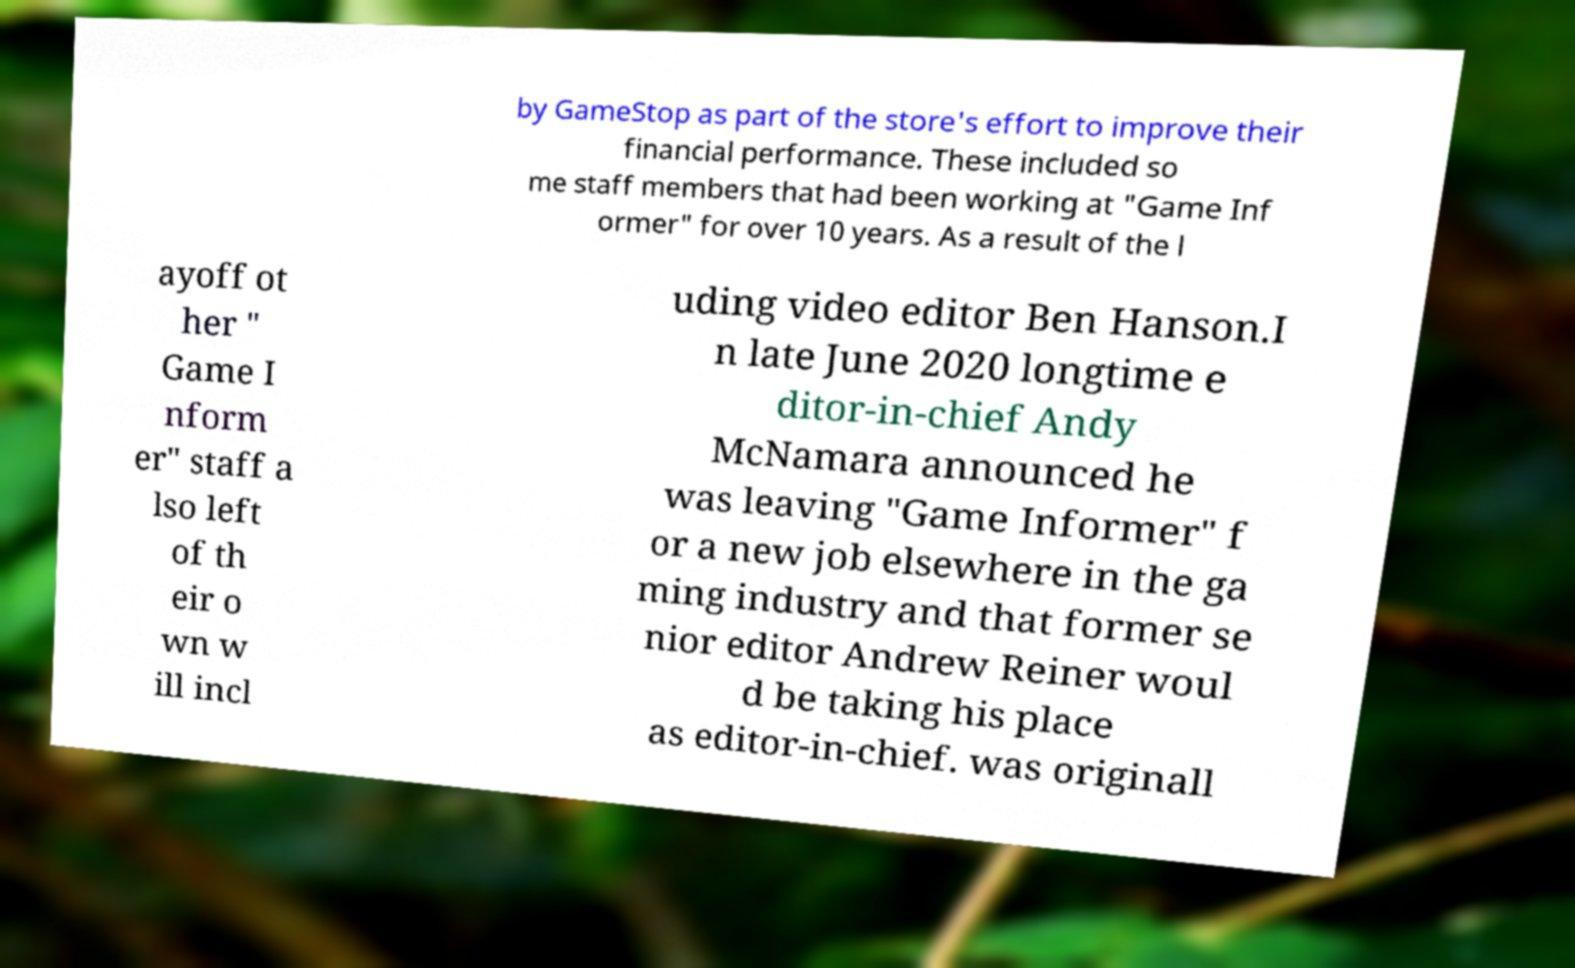There's text embedded in this image that I need extracted. Can you transcribe it verbatim? by GameStop as part of the store's effort to improve their financial performance. These included so me staff members that had been working at "Game Inf ormer" for over 10 years. As a result of the l ayoff ot her " Game I nform er" staff a lso left of th eir o wn w ill incl uding video editor Ben Hanson.I n late June 2020 longtime e ditor-in-chief Andy McNamara announced he was leaving "Game Informer" f or a new job elsewhere in the ga ming industry and that former se nior editor Andrew Reiner woul d be taking his place as editor-in-chief. was originall 